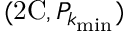<formula> <loc_0><loc_0><loc_500><loc_500>( 2 C , P _ { k _ { \min } } )</formula> 